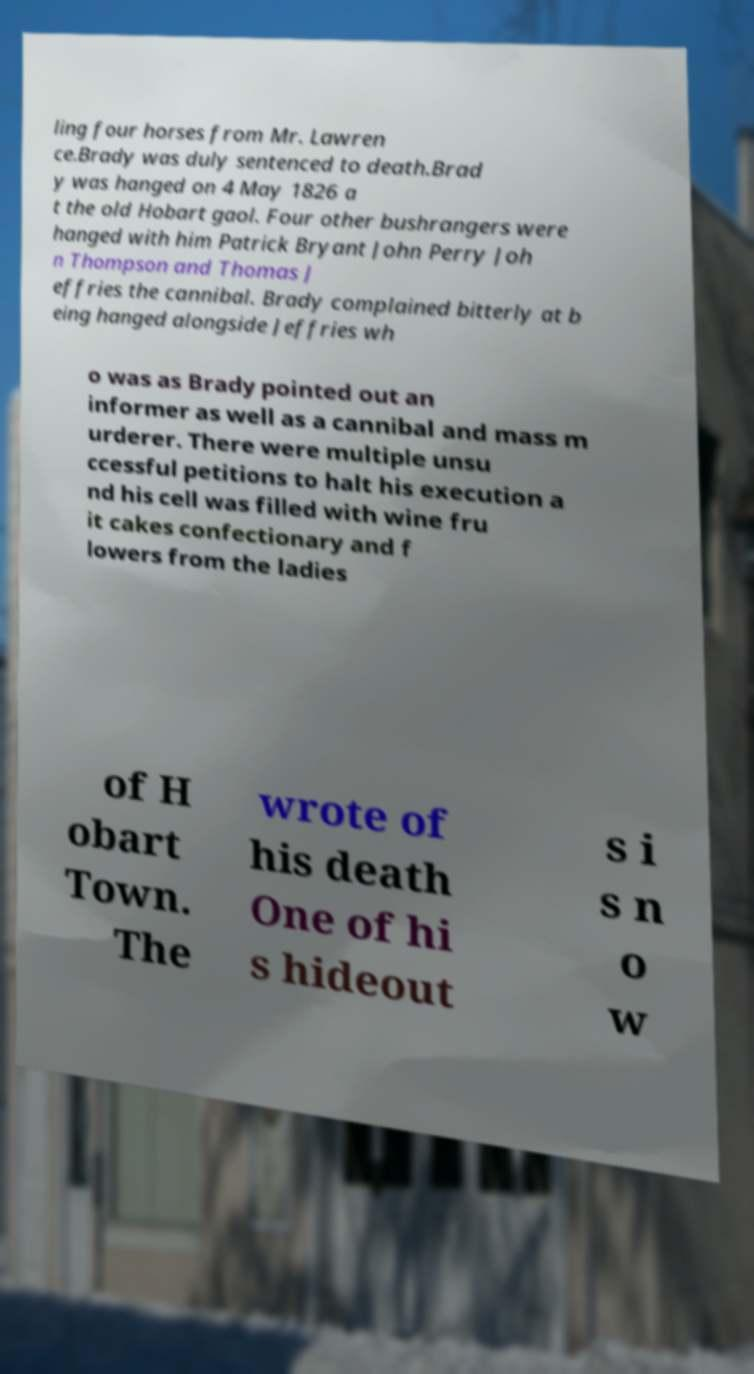For documentation purposes, I need the text within this image transcribed. Could you provide that? ling four horses from Mr. Lawren ce.Brady was duly sentenced to death.Brad y was hanged on 4 May 1826 a t the old Hobart gaol. Four other bushrangers were hanged with him Patrick Bryant John Perry Joh n Thompson and Thomas J effries the cannibal. Brady complained bitterly at b eing hanged alongside Jeffries wh o was as Brady pointed out an informer as well as a cannibal and mass m urderer. There were multiple unsu ccessful petitions to halt his execution a nd his cell was filled with wine fru it cakes confectionary and f lowers from the ladies of H obart Town. The wrote of his death One of hi s hideout s i s n o w 